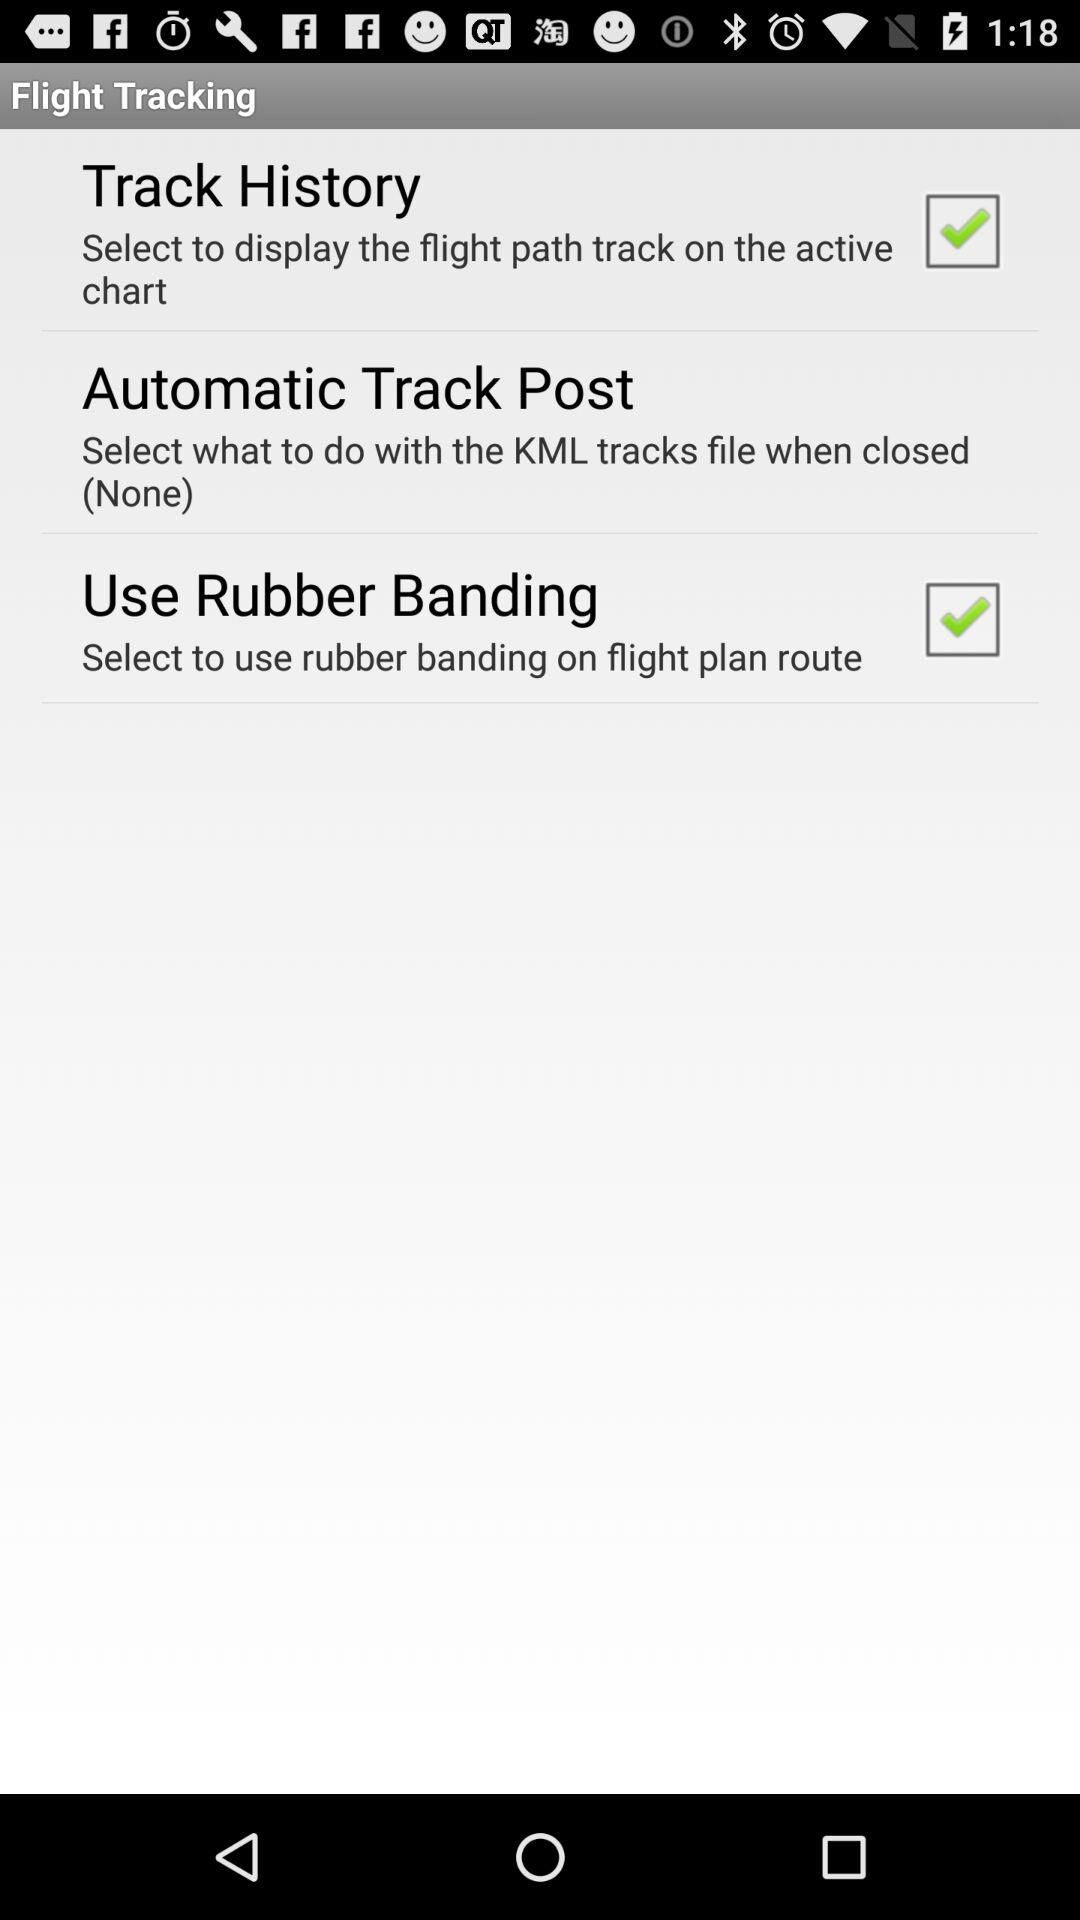How much history has been tracked?
When the provided information is insufficient, respond with <no answer>. <no answer> 